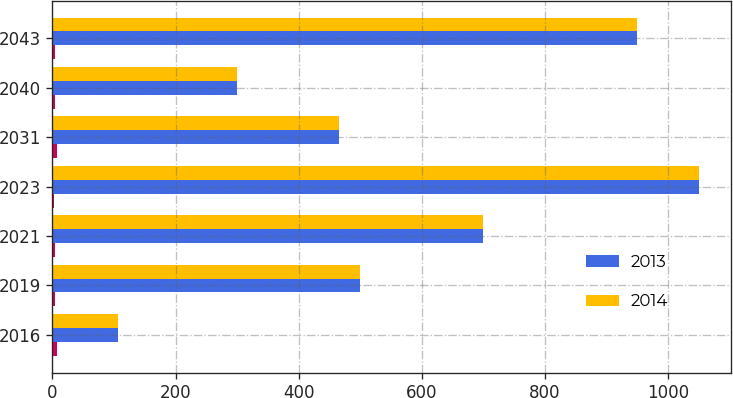Convert chart. <chart><loc_0><loc_0><loc_500><loc_500><stacked_bar_chart><ecel><fcel>2016<fcel>2019<fcel>2021<fcel>2023<fcel>2031<fcel>2040<fcel>2043<nl><fcel>nan<fcel>7.75<fcel>5.05<fcel>3.5<fcel>3.25<fcel>7.75<fcel>5.05<fcel>4.75<nl><fcel>2013<fcel>107<fcel>500<fcel>700<fcel>1050<fcel>466<fcel>300<fcel>950<nl><fcel>2014<fcel>107<fcel>500<fcel>700<fcel>1050<fcel>466<fcel>300<fcel>950<nl></chart> 